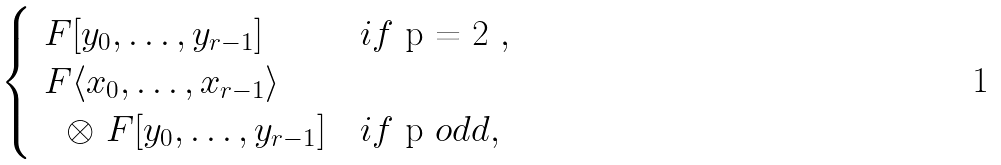<formula> <loc_0><loc_0><loc_500><loc_500>\begin{cases} \ F [ y _ { 0 } , \dots , y _ { r - 1 } ] & i f $ p = 2 $ , \\ \ F \langle x _ { 0 } , \dots , x _ { r - 1 } \rangle \\ \quad \otimes \ F [ y _ { 0 } , \dots , y _ { r - 1 } ] & i f $ p $ o d d , \end{cases}</formula> 